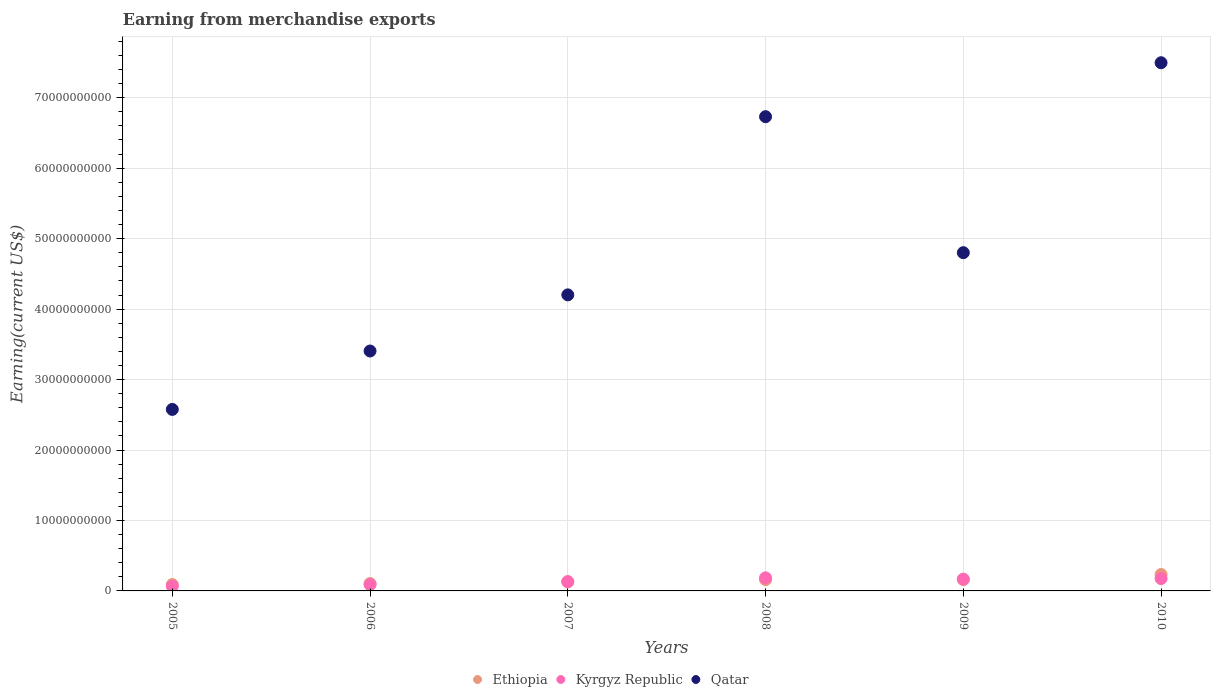Is the number of dotlines equal to the number of legend labels?
Offer a very short reply. Yes. What is the amount earned from merchandise exports in Kyrgyz Republic in 2009?
Your answer should be compact. 1.67e+09. Across all years, what is the maximum amount earned from merchandise exports in Kyrgyz Republic?
Your response must be concise. 1.86e+09. Across all years, what is the minimum amount earned from merchandise exports in Ethiopia?
Offer a terse response. 9.03e+08. In which year was the amount earned from merchandise exports in Qatar maximum?
Your answer should be very brief. 2010. What is the total amount earned from merchandise exports in Ethiopia in the graph?
Ensure brevity in your answer.  8.77e+09. What is the difference between the amount earned from merchandise exports in Qatar in 2008 and that in 2010?
Ensure brevity in your answer.  -7.66e+09. What is the difference between the amount earned from merchandise exports in Kyrgyz Republic in 2006 and the amount earned from merchandise exports in Qatar in 2010?
Provide a short and direct response. -7.41e+1. What is the average amount earned from merchandise exports in Qatar per year?
Make the answer very short. 4.87e+1. In the year 2006, what is the difference between the amount earned from merchandise exports in Ethiopia and amount earned from merchandise exports in Kyrgyz Republic?
Your answer should be compact. 1.52e+08. In how many years, is the amount earned from merchandise exports in Ethiopia greater than 60000000000 US$?
Make the answer very short. 0. What is the ratio of the amount earned from merchandise exports in Kyrgyz Republic in 2008 to that in 2009?
Your response must be concise. 1.11. What is the difference between the highest and the second highest amount earned from merchandise exports in Qatar?
Make the answer very short. 7.66e+09. What is the difference between the highest and the lowest amount earned from merchandise exports in Kyrgyz Republic?
Make the answer very short. 1.18e+09. Does the amount earned from merchandise exports in Ethiopia monotonically increase over the years?
Your answer should be compact. Yes. Does the graph contain any zero values?
Provide a short and direct response. No. Does the graph contain grids?
Make the answer very short. Yes. Where does the legend appear in the graph?
Ensure brevity in your answer.  Bottom center. How many legend labels are there?
Give a very brief answer. 3. How are the legend labels stacked?
Keep it short and to the point. Horizontal. What is the title of the graph?
Provide a succinct answer. Earning from merchandise exports. Does "Mexico" appear as one of the legend labels in the graph?
Provide a short and direct response. No. What is the label or title of the Y-axis?
Your answer should be very brief. Earning(current US$). What is the Earning(current US$) in Ethiopia in 2005?
Your answer should be compact. 9.03e+08. What is the Earning(current US$) in Kyrgyz Republic in 2005?
Ensure brevity in your answer.  6.72e+08. What is the Earning(current US$) of Qatar in 2005?
Provide a short and direct response. 2.58e+1. What is the Earning(current US$) in Ethiopia in 2006?
Offer a terse response. 1.04e+09. What is the Earning(current US$) of Kyrgyz Republic in 2006?
Make the answer very short. 8.91e+08. What is the Earning(current US$) of Qatar in 2006?
Ensure brevity in your answer.  3.41e+1. What is the Earning(current US$) of Ethiopia in 2007?
Provide a succinct answer. 1.28e+09. What is the Earning(current US$) in Kyrgyz Republic in 2007?
Your answer should be compact. 1.32e+09. What is the Earning(current US$) of Qatar in 2007?
Keep it short and to the point. 4.20e+1. What is the Earning(current US$) in Ethiopia in 2008?
Your answer should be compact. 1.60e+09. What is the Earning(current US$) in Kyrgyz Republic in 2008?
Offer a terse response. 1.86e+09. What is the Earning(current US$) of Qatar in 2008?
Offer a very short reply. 6.73e+1. What is the Earning(current US$) of Ethiopia in 2009?
Your answer should be very brief. 1.62e+09. What is the Earning(current US$) of Kyrgyz Republic in 2009?
Provide a short and direct response. 1.67e+09. What is the Earning(current US$) in Qatar in 2009?
Keep it short and to the point. 4.80e+1. What is the Earning(current US$) in Ethiopia in 2010?
Your response must be concise. 2.33e+09. What is the Earning(current US$) of Kyrgyz Republic in 2010?
Offer a very short reply. 1.76e+09. What is the Earning(current US$) in Qatar in 2010?
Your answer should be compact. 7.50e+1. Across all years, what is the maximum Earning(current US$) in Ethiopia?
Provide a succinct answer. 2.33e+09. Across all years, what is the maximum Earning(current US$) of Kyrgyz Republic?
Ensure brevity in your answer.  1.86e+09. Across all years, what is the maximum Earning(current US$) in Qatar?
Offer a very short reply. 7.50e+1. Across all years, what is the minimum Earning(current US$) in Ethiopia?
Offer a terse response. 9.03e+08. Across all years, what is the minimum Earning(current US$) of Kyrgyz Republic?
Offer a very short reply. 6.72e+08. Across all years, what is the minimum Earning(current US$) of Qatar?
Ensure brevity in your answer.  2.58e+1. What is the total Earning(current US$) of Ethiopia in the graph?
Provide a short and direct response. 8.77e+09. What is the total Earning(current US$) of Kyrgyz Republic in the graph?
Offer a very short reply. 8.17e+09. What is the total Earning(current US$) in Qatar in the graph?
Provide a short and direct response. 2.92e+11. What is the difference between the Earning(current US$) in Ethiopia in 2005 and that in 2006?
Make the answer very short. -1.40e+08. What is the difference between the Earning(current US$) of Kyrgyz Republic in 2005 and that in 2006?
Offer a very short reply. -2.19e+08. What is the difference between the Earning(current US$) in Qatar in 2005 and that in 2006?
Your response must be concise. -8.29e+09. What is the difference between the Earning(current US$) in Ethiopia in 2005 and that in 2007?
Offer a terse response. -3.74e+08. What is the difference between the Earning(current US$) in Kyrgyz Republic in 2005 and that in 2007?
Your answer should be very brief. -6.49e+08. What is the difference between the Earning(current US$) of Qatar in 2005 and that in 2007?
Your response must be concise. -1.63e+1. What is the difference between the Earning(current US$) of Ethiopia in 2005 and that in 2008?
Keep it short and to the point. -6.99e+08. What is the difference between the Earning(current US$) of Kyrgyz Republic in 2005 and that in 2008?
Provide a succinct answer. -1.18e+09. What is the difference between the Earning(current US$) in Qatar in 2005 and that in 2008?
Provide a short and direct response. -4.15e+1. What is the difference between the Earning(current US$) in Ethiopia in 2005 and that in 2009?
Keep it short and to the point. -7.15e+08. What is the difference between the Earning(current US$) in Kyrgyz Republic in 2005 and that in 2009?
Give a very brief answer. -1.00e+09. What is the difference between the Earning(current US$) in Qatar in 2005 and that in 2009?
Offer a very short reply. -2.22e+1. What is the difference between the Earning(current US$) of Ethiopia in 2005 and that in 2010?
Give a very brief answer. -1.43e+09. What is the difference between the Earning(current US$) in Kyrgyz Republic in 2005 and that in 2010?
Your answer should be compact. -1.08e+09. What is the difference between the Earning(current US$) in Qatar in 2005 and that in 2010?
Ensure brevity in your answer.  -4.92e+1. What is the difference between the Earning(current US$) of Ethiopia in 2006 and that in 2007?
Offer a terse response. -2.34e+08. What is the difference between the Earning(current US$) of Kyrgyz Republic in 2006 and that in 2007?
Your answer should be compact. -4.30e+08. What is the difference between the Earning(current US$) of Qatar in 2006 and that in 2007?
Ensure brevity in your answer.  -7.97e+09. What is the difference between the Earning(current US$) of Ethiopia in 2006 and that in 2008?
Ensure brevity in your answer.  -5.59e+08. What is the difference between the Earning(current US$) of Kyrgyz Republic in 2006 and that in 2008?
Give a very brief answer. -9.64e+08. What is the difference between the Earning(current US$) of Qatar in 2006 and that in 2008?
Provide a short and direct response. -3.33e+1. What is the difference between the Earning(current US$) in Ethiopia in 2006 and that in 2009?
Provide a short and direct response. -5.75e+08. What is the difference between the Earning(current US$) of Kyrgyz Republic in 2006 and that in 2009?
Offer a very short reply. -7.82e+08. What is the difference between the Earning(current US$) in Qatar in 2006 and that in 2009?
Offer a terse response. -1.40e+1. What is the difference between the Earning(current US$) in Ethiopia in 2006 and that in 2010?
Make the answer very short. -1.29e+09. What is the difference between the Earning(current US$) of Kyrgyz Republic in 2006 and that in 2010?
Your response must be concise. -8.65e+08. What is the difference between the Earning(current US$) in Qatar in 2006 and that in 2010?
Provide a short and direct response. -4.09e+1. What is the difference between the Earning(current US$) in Ethiopia in 2007 and that in 2008?
Your answer should be compact. -3.25e+08. What is the difference between the Earning(current US$) of Kyrgyz Republic in 2007 and that in 2008?
Offer a very short reply. -5.34e+08. What is the difference between the Earning(current US$) of Qatar in 2007 and that in 2008?
Offer a very short reply. -2.53e+1. What is the difference between the Earning(current US$) of Ethiopia in 2007 and that in 2009?
Your answer should be very brief. -3.41e+08. What is the difference between the Earning(current US$) in Kyrgyz Republic in 2007 and that in 2009?
Give a very brief answer. -3.52e+08. What is the difference between the Earning(current US$) in Qatar in 2007 and that in 2009?
Make the answer very short. -5.99e+09. What is the difference between the Earning(current US$) of Ethiopia in 2007 and that in 2010?
Provide a succinct answer. -1.05e+09. What is the difference between the Earning(current US$) of Kyrgyz Republic in 2007 and that in 2010?
Your response must be concise. -4.35e+08. What is the difference between the Earning(current US$) in Qatar in 2007 and that in 2010?
Keep it short and to the point. -3.29e+1. What is the difference between the Earning(current US$) in Ethiopia in 2008 and that in 2009?
Provide a short and direct response. -1.63e+07. What is the difference between the Earning(current US$) of Kyrgyz Republic in 2008 and that in 2009?
Give a very brief answer. 1.83e+08. What is the difference between the Earning(current US$) in Qatar in 2008 and that in 2009?
Keep it short and to the point. 1.93e+1. What is the difference between the Earning(current US$) of Ethiopia in 2008 and that in 2010?
Provide a succinct answer. -7.28e+08. What is the difference between the Earning(current US$) in Kyrgyz Republic in 2008 and that in 2010?
Ensure brevity in your answer.  9.97e+07. What is the difference between the Earning(current US$) in Qatar in 2008 and that in 2010?
Your answer should be compact. -7.66e+09. What is the difference between the Earning(current US$) in Ethiopia in 2009 and that in 2010?
Offer a terse response. -7.12e+08. What is the difference between the Earning(current US$) of Kyrgyz Republic in 2009 and that in 2010?
Give a very brief answer. -8.29e+07. What is the difference between the Earning(current US$) in Qatar in 2009 and that in 2010?
Ensure brevity in your answer.  -2.70e+1. What is the difference between the Earning(current US$) of Ethiopia in 2005 and the Earning(current US$) of Kyrgyz Republic in 2006?
Your answer should be compact. 1.19e+07. What is the difference between the Earning(current US$) in Ethiopia in 2005 and the Earning(current US$) in Qatar in 2006?
Give a very brief answer. -3.31e+1. What is the difference between the Earning(current US$) in Kyrgyz Republic in 2005 and the Earning(current US$) in Qatar in 2006?
Ensure brevity in your answer.  -3.34e+1. What is the difference between the Earning(current US$) in Ethiopia in 2005 and the Earning(current US$) in Kyrgyz Republic in 2007?
Ensure brevity in your answer.  -4.18e+08. What is the difference between the Earning(current US$) of Ethiopia in 2005 and the Earning(current US$) of Qatar in 2007?
Ensure brevity in your answer.  -4.11e+1. What is the difference between the Earning(current US$) in Kyrgyz Republic in 2005 and the Earning(current US$) in Qatar in 2007?
Offer a terse response. -4.13e+1. What is the difference between the Earning(current US$) in Ethiopia in 2005 and the Earning(current US$) in Kyrgyz Republic in 2008?
Your answer should be compact. -9.53e+08. What is the difference between the Earning(current US$) in Ethiopia in 2005 and the Earning(current US$) in Qatar in 2008?
Keep it short and to the point. -6.64e+1. What is the difference between the Earning(current US$) of Kyrgyz Republic in 2005 and the Earning(current US$) of Qatar in 2008?
Offer a very short reply. -6.66e+1. What is the difference between the Earning(current US$) in Ethiopia in 2005 and the Earning(current US$) in Kyrgyz Republic in 2009?
Provide a short and direct response. -7.70e+08. What is the difference between the Earning(current US$) in Ethiopia in 2005 and the Earning(current US$) in Qatar in 2009?
Keep it short and to the point. -4.71e+1. What is the difference between the Earning(current US$) of Kyrgyz Republic in 2005 and the Earning(current US$) of Qatar in 2009?
Your answer should be compact. -4.73e+1. What is the difference between the Earning(current US$) in Ethiopia in 2005 and the Earning(current US$) in Kyrgyz Republic in 2010?
Keep it short and to the point. -8.53e+08. What is the difference between the Earning(current US$) of Ethiopia in 2005 and the Earning(current US$) of Qatar in 2010?
Make the answer very short. -7.41e+1. What is the difference between the Earning(current US$) in Kyrgyz Republic in 2005 and the Earning(current US$) in Qatar in 2010?
Your answer should be very brief. -7.43e+1. What is the difference between the Earning(current US$) in Ethiopia in 2006 and the Earning(current US$) in Kyrgyz Republic in 2007?
Make the answer very short. -2.78e+08. What is the difference between the Earning(current US$) in Ethiopia in 2006 and the Earning(current US$) in Qatar in 2007?
Offer a very short reply. -4.10e+1. What is the difference between the Earning(current US$) of Kyrgyz Republic in 2006 and the Earning(current US$) of Qatar in 2007?
Make the answer very short. -4.11e+1. What is the difference between the Earning(current US$) of Ethiopia in 2006 and the Earning(current US$) of Kyrgyz Republic in 2008?
Give a very brief answer. -8.13e+08. What is the difference between the Earning(current US$) of Ethiopia in 2006 and the Earning(current US$) of Qatar in 2008?
Make the answer very short. -6.63e+1. What is the difference between the Earning(current US$) of Kyrgyz Republic in 2006 and the Earning(current US$) of Qatar in 2008?
Offer a very short reply. -6.64e+1. What is the difference between the Earning(current US$) in Ethiopia in 2006 and the Earning(current US$) in Kyrgyz Republic in 2009?
Give a very brief answer. -6.30e+08. What is the difference between the Earning(current US$) of Ethiopia in 2006 and the Earning(current US$) of Qatar in 2009?
Your answer should be very brief. -4.70e+1. What is the difference between the Earning(current US$) in Kyrgyz Republic in 2006 and the Earning(current US$) in Qatar in 2009?
Offer a terse response. -4.71e+1. What is the difference between the Earning(current US$) of Ethiopia in 2006 and the Earning(current US$) of Kyrgyz Republic in 2010?
Ensure brevity in your answer.  -7.13e+08. What is the difference between the Earning(current US$) in Ethiopia in 2006 and the Earning(current US$) in Qatar in 2010?
Make the answer very short. -7.39e+1. What is the difference between the Earning(current US$) of Kyrgyz Republic in 2006 and the Earning(current US$) of Qatar in 2010?
Your response must be concise. -7.41e+1. What is the difference between the Earning(current US$) in Ethiopia in 2007 and the Earning(current US$) in Kyrgyz Republic in 2008?
Keep it short and to the point. -5.78e+08. What is the difference between the Earning(current US$) in Ethiopia in 2007 and the Earning(current US$) in Qatar in 2008?
Provide a short and direct response. -6.60e+1. What is the difference between the Earning(current US$) in Kyrgyz Republic in 2007 and the Earning(current US$) in Qatar in 2008?
Provide a short and direct response. -6.60e+1. What is the difference between the Earning(current US$) in Ethiopia in 2007 and the Earning(current US$) in Kyrgyz Republic in 2009?
Offer a terse response. -3.96e+08. What is the difference between the Earning(current US$) in Ethiopia in 2007 and the Earning(current US$) in Qatar in 2009?
Offer a terse response. -4.67e+1. What is the difference between the Earning(current US$) in Kyrgyz Republic in 2007 and the Earning(current US$) in Qatar in 2009?
Ensure brevity in your answer.  -4.67e+1. What is the difference between the Earning(current US$) in Ethiopia in 2007 and the Earning(current US$) in Kyrgyz Republic in 2010?
Ensure brevity in your answer.  -4.79e+08. What is the difference between the Earning(current US$) of Ethiopia in 2007 and the Earning(current US$) of Qatar in 2010?
Provide a short and direct response. -7.37e+1. What is the difference between the Earning(current US$) in Kyrgyz Republic in 2007 and the Earning(current US$) in Qatar in 2010?
Keep it short and to the point. -7.36e+1. What is the difference between the Earning(current US$) of Ethiopia in 2008 and the Earning(current US$) of Kyrgyz Republic in 2009?
Give a very brief answer. -7.12e+07. What is the difference between the Earning(current US$) in Ethiopia in 2008 and the Earning(current US$) in Qatar in 2009?
Keep it short and to the point. -4.64e+1. What is the difference between the Earning(current US$) of Kyrgyz Republic in 2008 and the Earning(current US$) of Qatar in 2009?
Make the answer very short. -4.62e+1. What is the difference between the Earning(current US$) of Ethiopia in 2008 and the Earning(current US$) of Kyrgyz Republic in 2010?
Provide a short and direct response. -1.54e+08. What is the difference between the Earning(current US$) of Ethiopia in 2008 and the Earning(current US$) of Qatar in 2010?
Offer a very short reply. -7.34e+1. What is the difference between the Earning(current US$) of Kyrgyz Republic in 2008 and the Earning(current US$) of Qatar in 2010?
Offer a very short reply. -7.31e+1. What is the difference between the Earning(current US$) of Ethiopia in 2009 and the Earning(current US$) of Kyrgyz Republic in 2010?
Your response must be concise. -1.38e+08. What is the difference between the Earning(current US$) of Ethiopia in 2009 and the Earning(current US$) of Qatar in 2010?
Give a very brief answer. -7.33e+1. What is the difference between the Earning(current US$) in Kyrgyz Republic in 2009 and the Earning(current US$) in Qatar in 2010?
Provide a succinct answer. -7.33e+1. What is the average Earning(current US$) of Ethiopia per year?
Provide a succinct answer. 1.46e+09. What is the average Earning(current US$) of Kyrgyz Republic per year?
Provide a succinct answer. 1.36e+09. What is the average Earning(current US$) in Qatar per year?
Provide a succinct answer. 4.87e+1. In the year 2005, what is the difference between the Earning(current US$) of Ethiopia and Earning(current US$) of Kyrgyz Republic?
Keep it short and to the point. 2.31e+08. In the year 2005, what is the difference between the Earning(current US$) in Ethiopia and Earning(current US$) in Qatar?
Offer a very short reply. -2.49e+1. In the year 2005, what is the difference between the Earning(current US$) in Kyrgyz Republic and Earning(current US$) in Qatar?
Your answer should be very brief. -2.51e+1. In the year 2006, what is the difference between the Earning(current US$) of Ethiopia and Earning(current US$) of Kyrgyz Republic?
Offer a very short reply. 1.52e+08. In the year 2006, what is the difference between the Earning(current US$) of Ethiopia and Earning(current US$) of Qatar?
Provide a succinct answer. -3.30e+1. In the year 2006, what is the difference between the Earning(current US$) of Kyrgyz Republic and Earning(current US$) of Qatar?
Offer a very short reply. -3.32e+1. In the year 2007, what is the difference between the Earning(current US$) in Ethiopia and Earning(current US$) in Kyrgyz Republic?
Provide a short and direct response. -4.40e+07. In the year 2007, what is the difference between the Earning(current US$) of Ethiopia and Earning(current US$) of Qatar?
Provide a short and direct response. -4.07e+1. In the year 2007, what is the difference between the Earning(current US$) in Kyrgyz Republic and Earning(current US$) in Qatar?
Give a very brief answer. -4.07e+1. In the year 2008, what is the difference between the Earning(current US$) in Ethiopia and Earning(current US$) in Kyrgyz Republic?
Keep it short and to the point. -2.54e+08. In the year 2008, what is the difference between the Earning(current US$) of Ethiopia and Earning(current US$) of Qatar?
Provide a succinct answer. -6.57e+1. In the year 2008, what is the difference between the Earning(current US$) of Kyrgyz Republic and Earning(current US$) of Qatar?
Offer a very short reply. -6.55e+1. In the year 2009, what is the difference between the Earning(current US$) in Ethiopia and Earning(current US$) in Kyrgyz Republic?
Provide a succinct answer. -5.48e+07. In the year 2009, what is the difference between the Earning(current US$) of Ethiopia and Earning(current US$) of Qatar?
Your response must be concise. -4.64e+1. In the year 2009, what is the difference between the Earning(current US$) of Kyrgyz Republic and Earning(current US$) of Qatar?
Keep it short and to the point. -4.63e+1. In the year 2010, what is the difference between the Earning(current US$) in Ethiopia and Earning(current US$) in Kyrgyz Republic?
Make the answer very short. 5.74e+08. In the year 2010, what is the difference between the Earning(current US$) of Ethiopia and Earning(current US$) of Qatar?
Offer a very short reply. -7.26e+1. In the year 2010, what is the difference between the Earning(current US$) in Kyrgyz Republic and Earning(current US$) in Qatar?
Make the answer very short. -7.32e+1. What is the ratio of the Earning(current US$) in Ethiopia in 2005 to that in 2006?
Make the answer very short. 0.87. What is the ratio of the Earning(current US$) of Kyrgyz Republic in 2005 to that in 2006?
Your response must be concise. 0.75. What is the ratio of the Earning(current US$) in Qatar in 2005 to that in 2006?
Ensure brevity in your answer.  0.76. What is the ratio of the Earning(current US$) of Ethiopia in 2005 to that in 2007?
Provide a succinct answer. 0.71. What is the ratio of the Earning(current US$) of Kyrgyz Republic in 2005 to that in 2007?
Ensure brevity in your answer.  0.51. What is the ratio of the Earning(current US$) of Qatar in 2005 to that in 2007?
Make the answer very short. 0.61. What is the ratio of the Earning(current US$) in Ethiopia in 2005 to that in 2008?
Give a very brief answer. 0.56. What is the ratio of the Earning(current US$) in Kyrgyz Republic in 2005 to that in 2008?
Provide a succinct answer. 0.36. What is the ratio of the Earning(current US$) in Qatar in 2005 to that in 2008?
Your answer should be very brief. 0.38. What is the ratio of the Earning(current US$) in Ethiopia in 2005 to that in 2009?
Provide a succinct answer. 0.56. What is the ratio of the Earning(current US$) of Kyrgyz Republic in 2005 to that in 2009?
Keep it short and to the point. 0.4. What is the ratio of the Earning(current US$) of Qatar in 2005 to that in 2009?
Keep it short and to the point. 0.54. What is the ratio of the Earning(current US$) in Ethiopia in 2005 to that in 2010?
Your response must be concise. 0.39. What is the ratio of the Earning(current US$) of Kyrgyz Republic in 2005 to that in 2010?
Your response must be concise. 0.38. What is the ratio of the Earning(current US$) of Qatar in 2005 to that in 2010?
Ensure brevity in your answer.  0.34. What is the ratio of the Earning(current US$) of Ethiopia in 2006 to that in 2007?
Offer a very short reply. 0.82. What is the ratio of the Earning(current US$) of Kyrgyz Republic in 2006 to that in 2007?
Make the answer very short. 0.67. What is the ratio of the Earning(current US$) in Qatar in 2006 to that in 2007?
Make the answer very short. 0.81. What is the ratio of the Earning(current US$) of Ethiopia in 2006 to that in 2008?
Offer a very short reply. 0.65. What is the ratio of the Earning(current US$) of Kyrgyz Republic in 2006 to that in 2008?
Offer a very short reply. 0.48. What is the ratio of the Earning(current US$) in Qatar in 2006 to that in 2008?
Your answer should be compact. 0.51. What is the ratio of the Earning(current US$) in Ethiopia in 2006 to that in 2009?
Provide a succinct answer. 0.64. What is the ratio of the Earning(current US$) in Kyrgyz Republic in 2006 to that in 2009?
Offer a very short reply. 0.53. What is the ratio of the Earning(current US$) in Qatar in 2006 to that in 2009?
Keep it short and to the point. 0.71. What is the ratio of the Earning(current US$) in Ethiopia in 2006 to that in 2010?
Make the answer very short. 0.45. What is the ratio of the Earning(current US$) in Kyrgyz Republic in 2006 to that in 2010?
Provide a succinct answer. 0.51. What is the ratio of the Earning(current US$) of Qatar in 2006 to that in 2010?
Provide a short and direct response. 0.45. What is the ratio of the Earning(current US$) in Ethiopia in 2007 to that in 2008?
Your answer should be compact. 0.8. What is the ratio of the Earning(current US$) in Kyrgyz Republic in 2007 to that in 2008?
Your answer should be very brief. 0.71. What is the ratio of the Earning(current US$) in Qatar in 2007 to that in 2008?
Offer a very short reply. 0.62. What is the ratio of the Earning(current US$) of Ethiopia in 2007 to that in 2009?
Keep it short and to the point. 0.79. What is the ratio of the Earning(current US$) in Kyrgyz Republic in 2007 to that in 2009?
Keep it short and to the point. 0.79. What is the ratio of the Earning(current US$) of Qatar in 2007 to that in 2009?
Offer a very short reply. 0.88. What is the ratio of the Earning(current US$) of Ethiopia in 2007 to that in 2010?
Offer a very short reply. 0.55. What is the ratio of the Earning(current US$) of Kyrgyz Republic in 2007 to that in 2010?
Ensure brevity in your answer.  0.75. What is the ratio of the Earning(current US$) of Qatar in 2007 to that in 2010?
Give a very brief answer. 0.56. What is the ratio of the Earning(current US$) in Ethiopia in 2008 to that in 2009?
Make the answer very short. 0.99. What is the ratio of the Earning(current US$) of Kyrgyz Republic in 2008 to that in 2009?
Provide a succinct answer. 1.11. What is the ratio of the Earning(current US$) of Qatar in 2008 to that in 2009?
Ensure brevity in your answer.  1.4. What is the ratio of the Earning(current US$) in Ethiopia in 2008 to that in 2010?
Keep it short and to the point. 0.69. What is the ratio of the Earning(current US$) of Kyrgyz Republic in 2008 to that in 2010?
Give a very brief answer. 1.06. What is the ratio of the Earning(current US$) of Qatar in 2008 to that in 2010?
Your answer should be compact. 0.9. What is the ratio of the Earning(current US$) of Ethiopia in 2009 to that in 2010?
Offer a very short reply. 0.69. What is the ratio of the Earning(current US$) in Kyrgyz Republic in 2009 to that in 2010?
Provide a short and direct response. 0.95. What is the ratio of the Earning(current US$) of Qatar in 2009 to that in 2010?
Your answer should be compact. 0.64. What is the difference between the highest and the second highest Earning(current US$) of Ethiopia?
Offer a terse response. 7.12e+08. What is the difference between the highest and the second highest Earning(current US$) in Kyrgyz Republic?
Ensure brevity in your answer.  9.97e+07. What is the difference between the highest and the second highest Earning(current US$) in Qatar?
Ensure brevity in your answer.  7.66e+09. What is the difference between the highest and the lowest Earning(current US$) in Ethiopia?
Make the answer very short. 1.43e+09. What is the difference between the highest and the lowest Earning(current US$) in Kyrgyz Republic?
Provide a short and direct response. 1.18e+09. What is the difference between the highest and the lowest Earning(current US$) in Qatar?
Provide a short and direct response. 4.92e+1. 